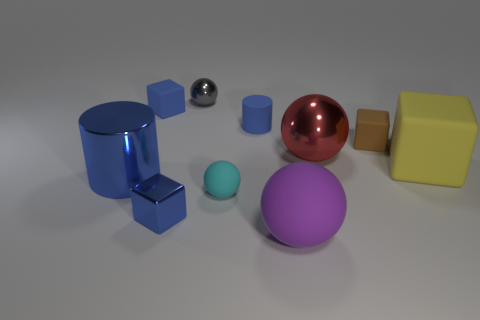Are there fewer large purple things on the right side of the red metal thing than blue metallic objects?
Give a very brief answer. Yes. What number of tiny rubber cylinders have the same color as the big cylinder?
Provide a short and direct response. 1. Are there fewer cyan metal things than small blue matte objects?
Keep it short and to the point. Yes. Does the gray ball have the same material as the brown thing?
Give a very brief answer. No. How many other things are there of the same size as the blue metal block?
Offer a terse response. 5. There is a big matte object that is in front of the small blue thing that is in front of the tiny cyan object; what is its color?
Offer a terse response. Purple. How many other things are there of the same shape as the brown object?
Make the answer very short. 3. Is there another tiny thing that has the same material as the tiny cyan object?
Ensure brevity in your answer.  Yes. There is a purple object that is the same size as the red metallic sphere; what is its material?
Give a very brief answer. Rubber. There is a large sphere in front of the tiny matte object that is in front of the cylinder that is in front of the small brown matte cube; what color is it?
Your answer should be very brief. Purple. 